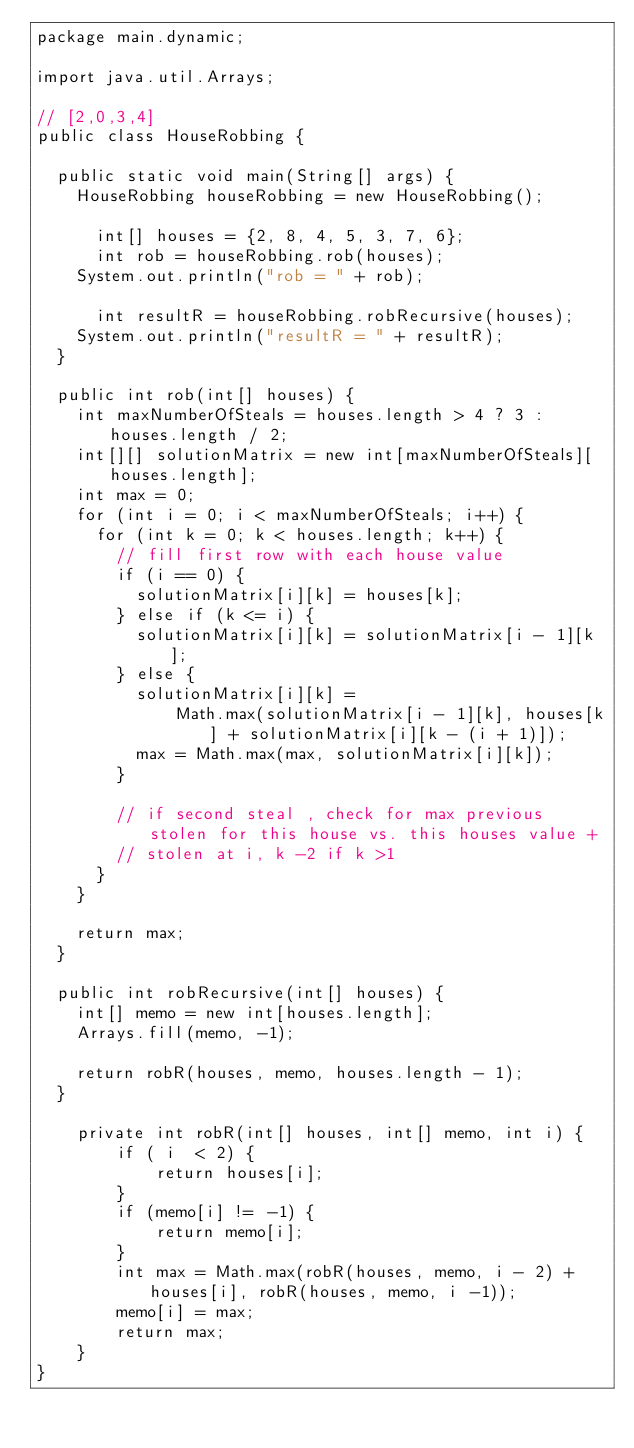<code> <loc_0><loc_0><loc_500><loc_500><_Java_>package main.dynamic;

import java.util.Arrays;

// [2,0,3,4]
public class HouseRobbing {

  public static void main(String[] args) {
    HouseRobbing houseRobbing = new HouseRobbing();

      int[] houses = {2, 8, 4, 5, 3, 7, 6};
      int rob = houseRobbing.rob(houses);
    System.out.println("rob = " + rob);

      int resultR = houseRobbing.robRecursive(houses);
    System.out.println("resultR = " + resultR);
  }

  public int rob(int[] houses) {
    int maxNumberOfSteals = houses.length > 4 ? 3 : houses.length / 2;
    int[][] solutionMatrix = new int[maxNumberOfSteals][houses.length];
    int max = 0;
    for (int i = 0; i < maxNumberOfSteals; i++) {
      for (int k = 0; k < houses.length; k++) {
        // fill first row with each house value
        if (i == 0) {
          solutionMatrix[i][k] = houses[k];
        } else if (k <= i) {
          solutionMatrix[i][k] = solutionMatrix[i - 1][k];
        } else {
          solutionMatrix[i][k] =
              Math.max(solutionMatrix[i - 1][k], houses[k] + solutionMatrix[i][k - (i + 1)]);
          max = Math.max(max, solutionMatrix[i][k]);
        }

        // if second steal , check for max previous stolen for this house vs. this houses value +
        // stolen at i, k -2 if k >1
      }
    }

    return max;
  }

  public int robRecursive(int[] houses) {
    int[] memo = new int[houses.length];
    Arrays.fill(memo, -1);

    return robR(houses, memo, houses.length - 1);
  }

    private int robR(int[] houses, int[] memo, int i) {
        if ( i  < 2) {
            return houses[i];
        }
        if (memo[i] != -1) {
            return memo[i];
        }
        int max = Math.max(robR(houses, memo, i - 2) + houses[i], robR(houses, memo, i -1));
        memo[i] = max;
        return max;
    }
}
</code> 